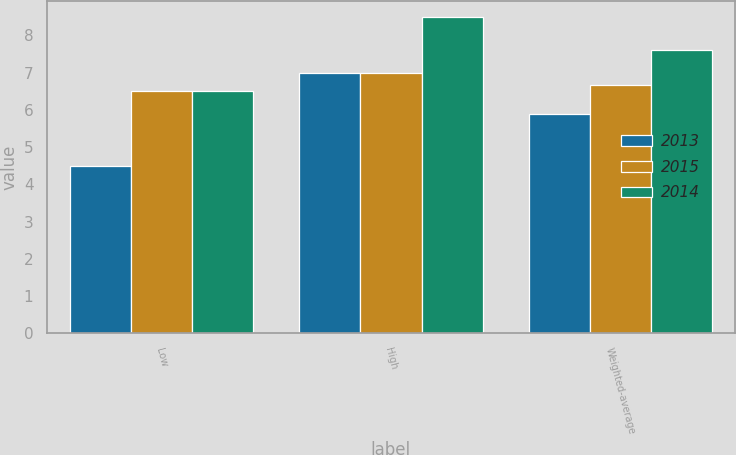Convert chart. <chart><loc_0><loc_0><loc_500><loc_500><stacked_bar_chart><ecel><fcel>Low<fcel>High<fcel>Weighted-average<nl><fcel>2013<fcel>4.5<fcel>7<fcel>5.9<nl><fcel>2015<fcel>6.5<fcel>7<fcel>6.66<nl><fcel>2014<fcel>6.5<fcel>8.5<fcel>7.6<nl></chart> 